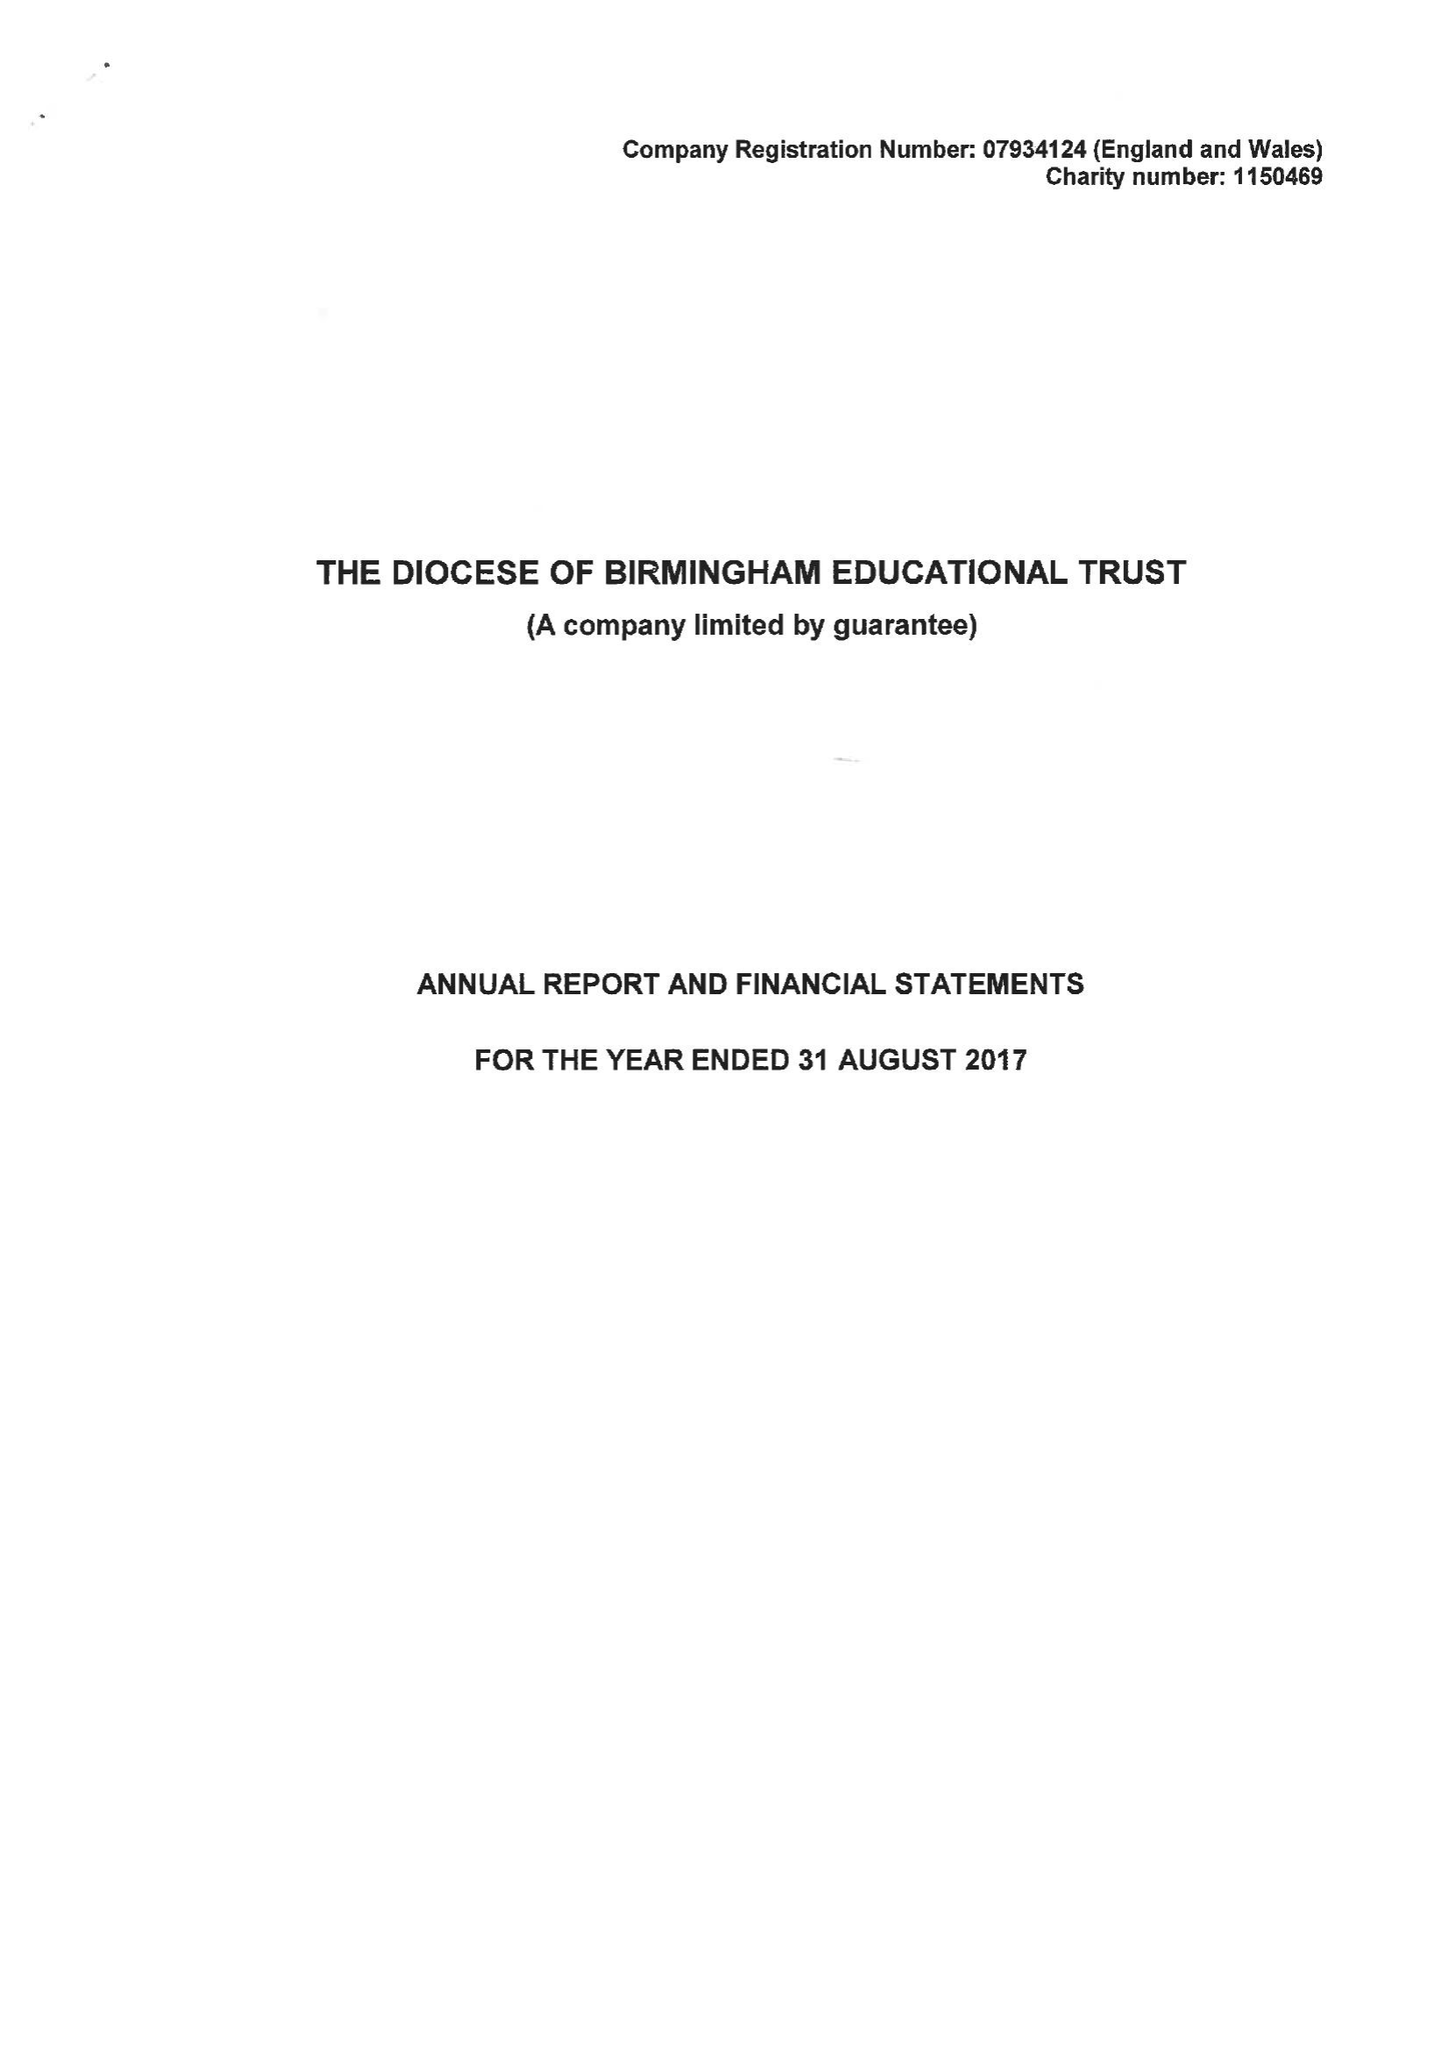What is the value for the address__street_line?
Answer the question using a single word or phrase. 1 COLMORE ROW 